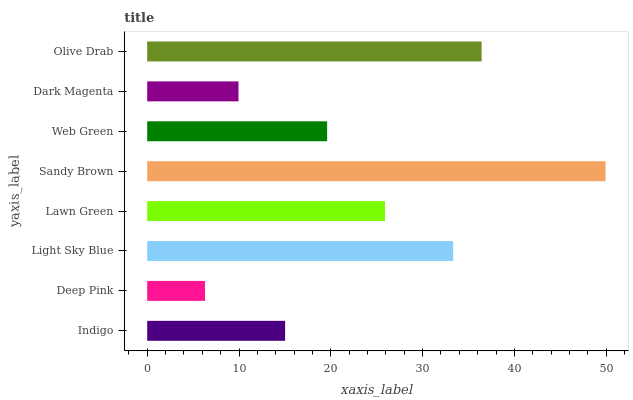Is Deep Pink the minimum?
Answer yes or no. Yes. Is Sandy Brown the maximum?
Answer yes or no. Yes. Is Light Sky Blue the minimum?
Answer yes or no. No. Is Light Sky Blue the maximum?
Answer yes or no. No. Is Light Sky Blue greater than Deep Pink?
Answer yes or no. Yes. Is Deep Pink less than Light Sky Blue?
Answer yes or no. Yes. Is Deep Pink greater than Light Sky Blue?
Answer yes or no. No. Is Light Sky Blue less than Deep Pink?
Answer yes or no. No. Is Lawn Green the high median?
Answer yes or no. Yes. Is Web Green the low median?
Answer yes or no. Yes. Is Sandy Brown the high median?
Answer yes or no. No. Is Lawn Green the low median?
Answer yes or no. No. 